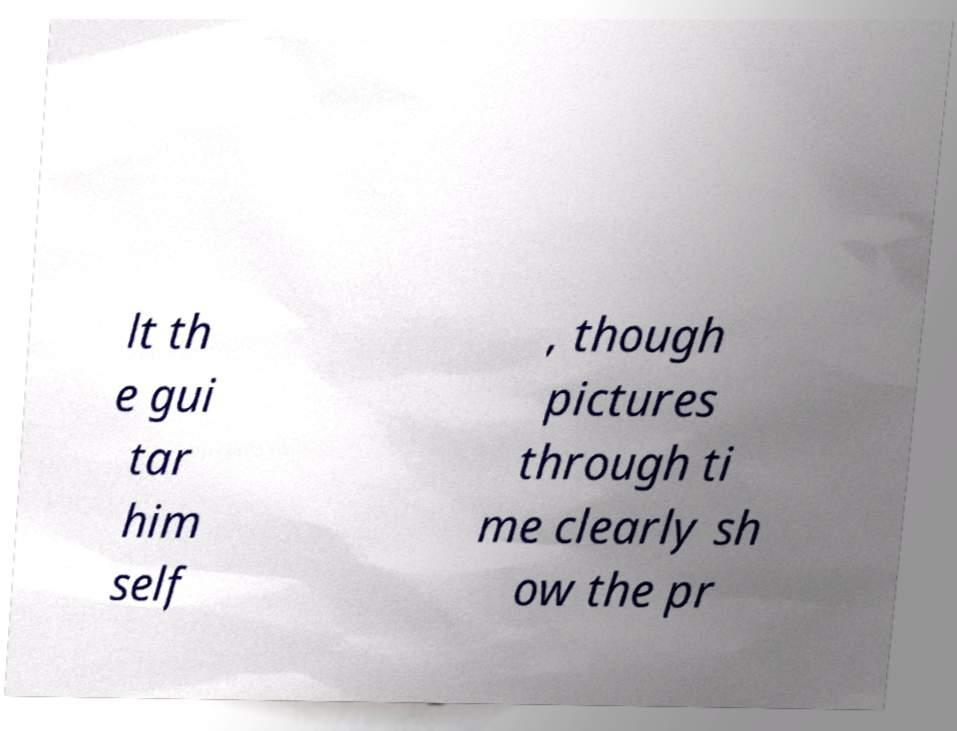There's text embedded in this image that I need extracted. Can you transcribe it verbatim? lt th e gui tar him self , though pictures through ti me clearly sh ow the pr 